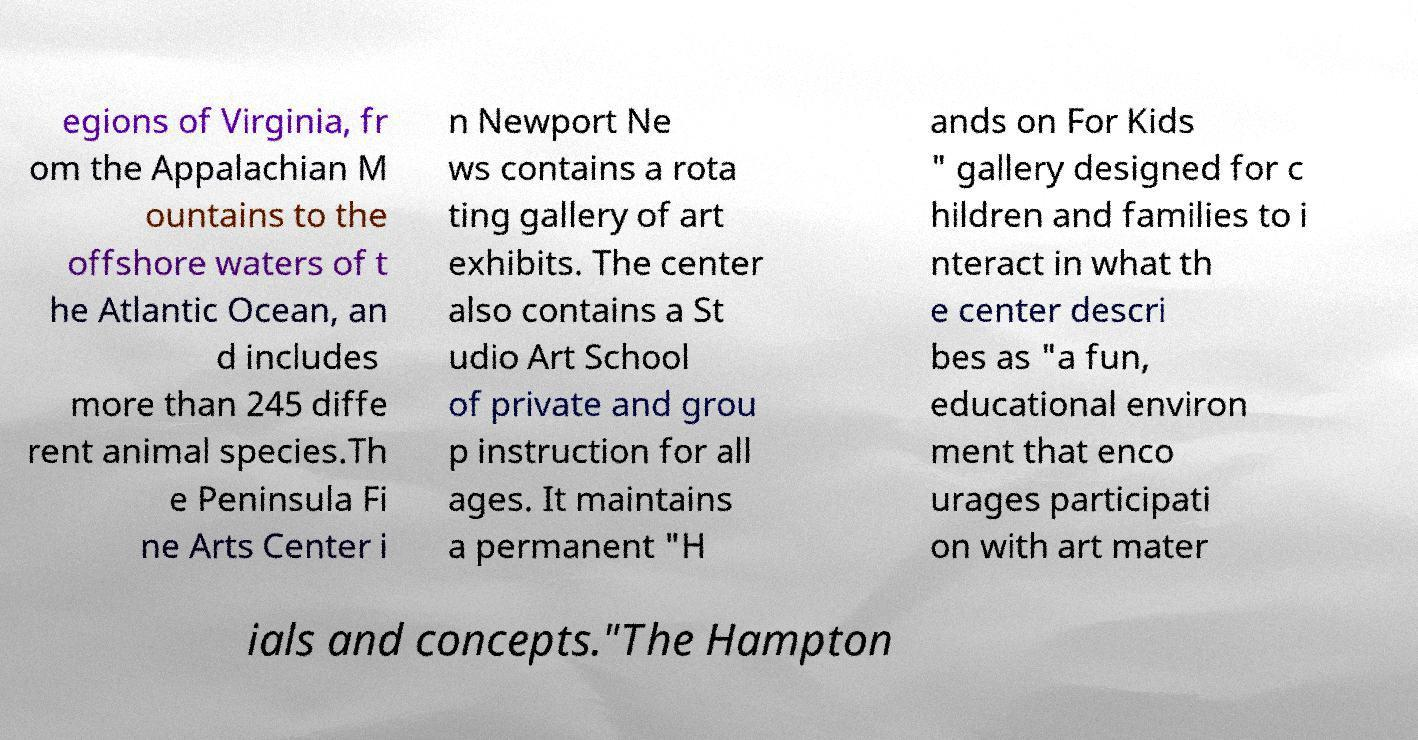Could you assist in decoding the text presented in this image and type it out clearly? egions of Virginia, fr om the Appalachian M ountains to the offshore waters of t he Atlantic Ocean, an d includes more than 245 diffe rent animal species.Th e Peninsula Fi ne Arts Center i n Newport Ne ws contains a rota ting gallery of art exhibits. The center also contains a St udio Art School of private and grou p instruction for all ages. It maintains a permanent "H ands on For Kids " gallery designed for c hildren and families to i nteract in what th e center descri bes as "a fun, educational environ ment that enco urages participati on with art mater ials and concepts."The Hampton 